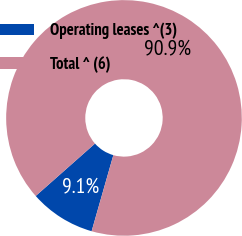Convert chart to OTSL. <chart><loc_0><loc_0><loc_500><loc_500><pie_chart><fcel>Operating leases ^(3)<fcel>Total ^ (6)<nl><fcel>9.05%<fcel>90.95%<nl></chart> 